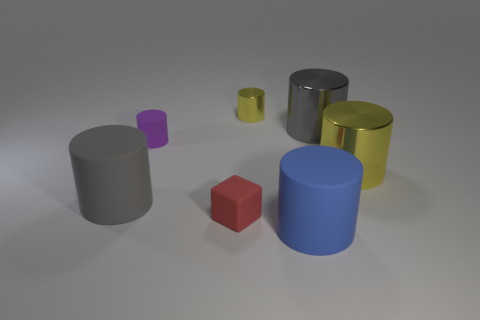What number of objects are cylinders to the right of the large blue thing or gray objects that are on the right side of the blue rubber cylinder?
Provide a succinct answer. 2. How many other things are the same color as the tiny cube?
Your answer should be very brief. 0. Are there more big cylinders that are on the left side of the large gray rubber cylinder than tiny things that are in front of the small rubber block?
Provide a succinct answer. No. How many balls are large metallic things or small rubber objects?
Offer a terse response. 0. How many things are shiny things that are behind the gray metal cylinder or shiny cylinders?
Give a very brief answer. 3. The large gray thing that is behind the yellow thing that is on the right side of the yellow metal object behind the large gray metal cylinder is what shape?
Make the answer very short. Cylinder. How many tiny yellow objects have the same shape as the purple object?
Provide a short and direct response. 1. There is a large cylinder that is the same color as the small shiny object; what is its material?
Offer a very short reply. Metal. Are the small yellow object and the red thing made of the same material?
Provide a short and direct response. No. There is a large gray object to the right of the tiny object on the left side of the small red matte block; how many shiny objects are behind it?
Give a very brief answer. 1. 